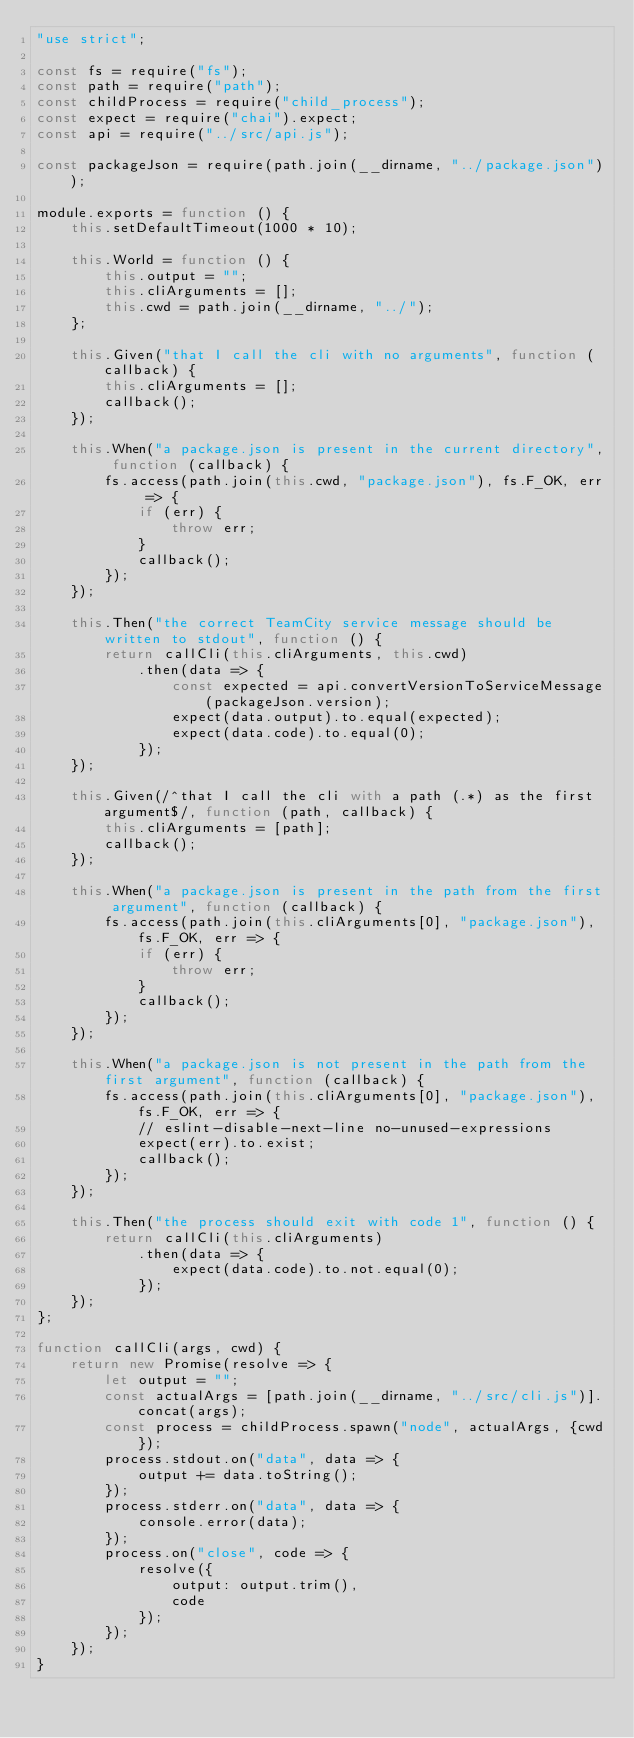Convert code to text. <code><loc_0><loc_0><loc_500><loc_500><_JavaScript_>"use strict";

const fs = require("fs");
const path = require("path");
const childProcess = require("child_process");
const expect = require("chai").expect;
const api = require("../src/api.js");

const packageJson = require(path.join(__dirname, "../package.json"));

module.exports = function () {
	this.setDefaultTimeout(1000 * 10);

	this.World = function () {
		this.output = "";
		this.cliArguments = [];
		this.cwd = path.join(__dirname, "../");
	};

	this.Given("that I call the cli with no arguments", function (callback) {
		this.cliArguments = [];
		callback();
	});

	this.When("a package.json is present in the current directory", function (callback) {
		fs.access(path.join(this.cwd, "package.json"), fs.F_OK, err => {
			if (err) {
				throw err;
			}
			callback();
		});
	});

	this.Then("the correct TeamCity service message should be written to stdout", function () {
		return callCli(this.cliArguments, this.cwd)
			.then(data => {
				const expected = api.convertVersionToServiceMessage(packageJson.version);
				expect(data.output).to.equal(expected);
				expect(data.code).to.equal(0);
			});
	});

	this.Given(/^that I call the cli with a path (.*) as the first argument$/, function (path, callback) {
		this.cliArguments = [path];
		callback();
	});

	this.When("a package.json is present in the path from the first argument", function (callback) {
		fs.access(path.join(this.cliArguments[0], "package.json"), fs.F_OK, err => {
			if (err) {
				throw err;
			}
			callback();
		});
	});

	this.When("a package.json is not present in the path from the first argument", function (callback) {
		fs.access(path.join(this.cliArguments[0], "package.json"), fs.F_OK, err => {
			// eslint-disable-next-line no-unused-expressions
			expect(err).to.exist;
			callback();
		});
	});

	this.Then("the process should exit with code 1", function () {
		return callCli(this.cliArguments)
			.then(data => {
				expect(data.code).to.not.equal(0);
			});
	});
};

function callCli(args, cwd) {
	return new Promise(resolve => {
		let output = "";
		const actualArgs = [path.join(__dirname, "../src/cli.js")].concat(args);
		const process = childProcess.spawn("node", actualArgs, {cwd});
		process.stdout.on("data", data => {
			output += data.toString();
		});
		process.stderr.on("data", data => {
			console.error(data);
		});
		process.on("close", code => {
			resolve({
				output: output.trim(),
				code
			});
		});
	});
}
</code> 